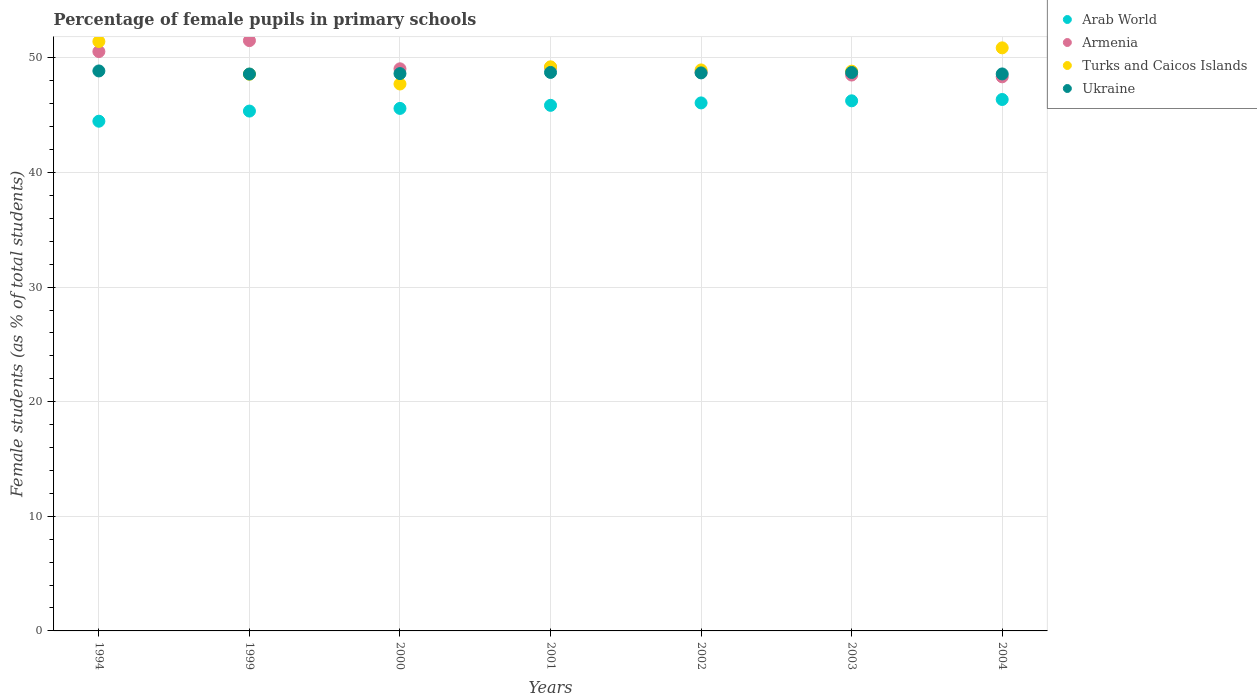How many different coloured dotlines are there?
Your answer should be compact. 4. Is the number of dotlines equal to the number of legend labels?
Offer a very short reply. Yes. What is the percentage of female pupils in primary schools in Arab World in 2000?
Offer a terse response. 45.59. Across all years, what is the maximum percentage of female pupils in primary schools in Arab World?
Your answer should be compact. 46.37. Across all years, what is the minimum percentage of female pupils in primary schools in Armenia?
Ensure brevity in your answer.  48.35. In which year was the percentage of female pupils in primary schools in Turks and Caicos Islands maximum?
Offer a very short reply. 1994. What is the total percentage of female pupils in primary schools in Turks and Caicos Islands in the graph?
Provide a succinct answer. 345.6. What is the difference between the percentage of female pupils in primary schools in Turks and Caicos Islands in 1999 and that in 2001?
Your response must be concise. -0.65. What is the difference between the percentage of female pupils in primary schools in Armenia in 2004 and the percentage of female pupils in primary schools in Ukraine in 2002?
Offer a very short reply. -0.34. What is the average percentage of female pupils in primary schools in Ukraine per year?
Offer a very short reply. 48.69. In the year 2002, what is the difference between the percentage of female pupils in primary schools in Ukraine and percentage of female pupils in primary schools in Arab World?
Your answer should be very brief. 2.62. In how many years, is the percentage of female pupils in primary schools in Armenia greater than 38 %?
Provide a succinct answer. 7. What is the ratio of the percentage of female pupils in primary schools in Turks and Caicos Islands in 2001 to that in 2003?
Provide a short and direct response. 1.01. Is the percentage of female pupils in primary schools in Arab World in 1999 less than that in 2003?
Provide a short and direct response. Yes. Is the difference between the percentage of female pupils in primary schools in Ukraine in 2003 and 2004 greater than the difference between the percentage of female pupils in primary schools in Arab World in 2003 and 2004?
Your response must be concise. Yes. What is the difference between the highest and the second highest percentage of female pupils in primary schools in Ukraine?
Ensure brevity in your answer.  0.13. What is the difference between the highest and the lowest percentage of female pupils in primary schools in Armenia?
Keep it short and to the point. 3.16. Is it the case that in every year, the sum of the percentage of female pupils in primary schools in Armenia and percentage of female pupils in primary schools in Arab World  is greater than the percentage of female pupils in primary schools in Ukraine?
Your answer should be very brief. Yes. Is the percentage of female pupils in primary schools in Turks and Caicos Islands strictly greater than the percentage of female pupils in primary schools in Ukraine over the years?
Keep it short and to the point. No. How many years are there in the graph?
Provide a succinct answer. 7. What is the difference between two consecutive major ticks on the Y-axis?
Provide a succinct answer. 10. How are the legend labels stacked?
Your response must be concise. Vertical. What is the title of the graph?
Provide a short and direct response. Percentage of female pupils in primary schools. Does "Bulgaria" appear as one of the legend labels in the graph?
Your answer should be compact. No. What is the label or title of the X-axis?
Offer a terse response. Years. What is the label or title of the Y-axis?
Your answer should be compact. Female students (as % of total students). What is the Female students (as % of total students) in Arab World in 1994?
Provide a succinct answer. 44.47. What is the Female students (as % of total students) of Armenia in 1994?
Offer a very short reply. 50.55. What is the Female students (as % of total students) in Turks and Caicos Islands in 1994?
Provide a short and direct response. 51.43. What is the Female students (as % of total students) of Ukraine in 1994?
Give a very brief answer. 48.86. What is the Female students (as % of total students) in Arab World in 1999?
Your answer should be very brief. 45.36. What is the Female students (as % of total students) of Armenia in 1999?
Your answer should be very brief. 51.51. What is the Female students (as % of total students) of Turks and Caicos Islands in 1999?
Provide a short and direct response. 48.57. What is the Female students (as % of total students) of Ukraine in 1999?
Your answer should be very brief. 48.59. What is the Female students (as % of total students) in Arab World in 2000?
Offer a very short reply. 45.59. What is the Female students (as % of total students) of Armenia in 2000?
Your answer should be compact. 49.05. What is the Female students (as % of total students) in Turks and Caicos Islands in 2000?
Provide a short and direct response. 47.72. What is the Female students (as % of total students) in Ukraine in 2000?
Make the answer very short. 48.63. What is the Female students (as % of total students) of Arab World in 2001?
Provide a short and direct response. 45.86. What is the Female students (as % of total students) in Armenia in 2001?
Give a very brief answer. 49.17. What is the Female students (as % of total students) of Turks and Caicos Islands in 2001?
Provide a succinct answer. 49.22. What is the Female students (as % of total students) of Ukraine in 2001?
Offer a very short reply. 48.73. What is the Female students (as % of total students) in Arab World in 2002?
Provide a succinct answer. 46.07. What is the Female students (as % of total students) in Armenia in 2002?
Offer a terse response. 48.74. What is the Female students (as % of total students) in Turks and Caicos Islands in 2002?
Your response must be concise. 48.95. What is the Female students (as % of total students) in Ukraine in 2002?
Your response must be concise. 48.69. What is the Female students (as % of total students) of Arab World in 2003?
Your answer should be very brief. 46.25. What is the Female students (as % of total students) of Armenia in 2003?
Make the answer very short. 48.5. What is the Female students (as % of total students) in Turks and Caicos Islands in 2003?
Offer a very short reply. 48.84. What is the Female students (as % of total students) in Ukraine in 2003?
Give a very brief answer. 48.72. What is the Female students (as % of total students) in Arab World in 2004?
Offer a terse response. 46.37. What is the Female students (as % of total students) of Armenia in 2004?
Provide a short and direct response. 48.35. What is the Female students (as % of total students) in Turks and Caicos Islands in 2004?
Give a very brief answer. 50.87. What is the Female students (as % of total students) of Ukraine in 2004?
Provide a succinct answer. 48.6. Across all years, what is the maximum Female students (as % of total students) of Arab World?
Give a very brief answer. 46.37. Across all years, what is the maximum Female students (as % of total students) in Armenia?
Give a very brief answer. 51.51. Across all years, what is the maximum Female students (as % of total students) in Turks and Caicos Islands?
Offer a very short reply. 51.43. Across all years, what is the maximum Female students (as % of total students) of Ukraine?
Offer a terse response. 48.86. Across all years, what is the minimum Female students (as % of total students) of Arab World?
Make the answer very short. 44.47. Across all years, what is the minimum Female students (as % of total students) of Armenia?
Offer a terse response. 48.35. Across all years, what is the minimum Female students (as % of total students) of Turks and Caicos Islands?
Your answer should be compact. 47.72. Across all years, what is the minimum Female students (as % of total students) of Ukraine?
Your answer should be very brief. 48.59. What is the total Female students (as % of total students) in Arab World in the graph?
Offer a very short reply. 319.97. What is the total Female students (as % of total students) of Armenia in the graph?
Give a very brief answer. 345.87. What is the total Female students (as % of total students) of Turks and Caicos Islands in the graph?
Provide a short and direct response. 345.6. What is the total Female students (as % of total students) in Ukraine in the graph?
Provide a succinct answer. 340.82. What is the difference between the Female students (as % of total students) of Arab World in 1994 and that in 1999?
Keep it short and to the point. -0.88. What is the difference between the Female students (as % of total students) of Armenia in 1994 and that in 1999?
Offer a very short reply. -0.95. What is the difference between the Female students (as % of total students) in Turks and Caicos Islands in 1994 and that in 1999?
Your answer should be compact. 2.86. What is the difference between the Female students (as % of total students) of Ukraine in 1994 and that in 1999?
Your response must be concise. 0.27. What is the difference between the Female students (as % of total students) of Arab World in 1994 and that in 2000?
Your answer should be very brief. -1.12. What is the difference between the Female students (as % of total students) in Armenia in 1994 and that in 2000?
Make the answer very short. 1.51. What is the difference between the Female students (as % of total students) in Turks and Caicos Islands in 1994 and that in 2000?
Provide a short and direct response. 3.71. What is the difference between the Female students (as % of total students) in Ukraine in 1994 and that in 2000?
Give a very brief answer. 0.23. What is the difference between the Female students (as % of total students) of Arab World in 1994 and that in 2001?
Keep it short and to the point. -1.38. What is the difference between the Female students (as % of total students) of Armenia in 1994 and that in 2001?
Your answer should be very brief. 1.38. What is the difference between the Female students (as % of total students) of Turks and Caicos Islands in 1994 and that in 2001?
Keep it short and to the point. 2.21. What is the difference between the Female students (as % of total students) in Ukraine in 1994 and that in 2001?
Give a very brief answer. 0.13. What is the difference between the Female students (as % of total students) in Arab World in 1994 and that in 2002?
Ensure brevity in your answer.  -1.6. What is the difference between the Female students (as % of total students) of Armenia in 1994 and that in 2002?
Keep it short and to the point. 1.81. What is the difference between the Female students (as % of total students) in Turks and Caicos Islands in 1994 and that in 2002?
Your answer should be very brief. 2.48. What is the difference between the Female students (as % of total students) of Ukraine in 1994 and that in 2002?
Your answer should be very brief. 0.17. What is the difference between the Female students (as % of total students) in Arab World in 1994 and that in 2003?
Give a very brief answer. -1.78. What is the difference between the Female students (as % of total students) in Armenia in 1994 and that in 2003?
Your response must be concise. 2.05. What is the difference between the Female students (as % of total students) of Turks and Caicos Islands in 1994 and that in 2003?
Your answer should be compact. 2.59. What is the difference between the Female students (as % of total students) of Ukraine in 1994 and that in 2003?
Give a very brief answer. 0.13. What is the difference between the Female students (as % of total students) in Arab World in 1994 and that in 2004?
Ensure brevity in your answer.  -1.9. What is the difference between the Female students (as % of total students) in Armenia in 1994 and that in 2004?
Offer a terse response. 2.2. What is the difference between the Female students (as % of total students) of Turks and Caicos Islands in 1994 and that in 2004?
Make the answer very short. 0.55. What is the difference between the Female students (as % of total students) in Ukraine in 1994 and that in 2004?
Your answer should be compact. 0.26. What is the difference between the Female students (as % of total students) of Arab World in 1999 and that in 2000?
Your response must be concise. -0.23. What is the difference between the Female students (as % of total students) in Armenia in 1999 and that in 2000?
Keep it short and to the point. 2.46. What is the difference between the Female students (as % of total students) in Turks and Caicos Islands in 1999 and that in 2000?
Your response must be concise. 0.85. What is the difference between the Female students (as % of total students) in Ukraine in 1999 and that in 2000?
Offer a very short reply. -0.04. What is the difference between the Female students (as % of total students) in Arab World in 1999 and that in 2001?
Provide a short and direct response. -0.5. What is the difference between the Female students (as % of total students) of Armenia in 1999 and that in 2001?
Ensure brevity in your answer.  2.33. What is the difference between the Female students (as % of total students) in Turks and Caicos Islands in 1999 and that in 2001?
Provide a succinct answer. -0.65. What is the difference between the Female students (as % of total students) in Ukraine in 1999 and that in 2001?
Give a very brief answer. -0.14. What is the difference between the Female students (as % of total students) in Arab World in 1999 and that in 2002?
Make the answer very short. -0.71. What is the difference between the Female students (as % of total students) of Armenia in 1999 and that in 2002?
Ensure brevity in your answer.  2.77. What is the difference between the Female students (as % of total students) of Turks and Caicos Islands in 1999 and that in 2002?
Your answer should be very brief. -0.37. What is the difference between the Female students (as % of total students) of Ukraine in 1999 and that in 2002?
Make the answer very short. -0.1. What is the difference between the Female students (as % of total students) of Arab World in 1999 and that in 2003?
Offer a terse response. -0.9. What is the difference between the Female students (as % of total students) of Armenia in 1999 and that in 2003?
Provide a short and direct response. 3. What is the difference between the Female students (as % of total students) of Turks and Caicos Islands in 1999 and that in 2003?
Keep it short and to the point. -0.27. What is the difference between the Female students (as % of total students) in Ukraine in 1999 and that in 2003?
Ensure brevity in your answer.  -0.13. What is the difference between the Female students (as % of total students) in Arab World in 1999 and that in 2004?
Your answer should be compact. -1.01. What is the difference between the Female students (as % of total students) of Armenia in 1999 and that in 2004?
Offer a terse response. 3.16. What is the difference between the Female students (as % of total students) in Turks and Caicos Islands in 1999 and that in 2004?
Offer a terse response. -2.3. What is the difference between the Female students (as % of total students) in Ukraine in 1999 and that in 2004?
Your answer should be very brief. -0.01. What is the difference between the Female students (as % of total students) of Arab World in 2000 and that in 2001?
Make the answer very short. -0.27. What is the difference between the Female students (as % of total students) of Armenia in 2000 and that in 2001?
Your answer should be very brief. -0.13. What is the difference between the Female students (as % of total students) of Turks and Caicos Islands in 2000 and that in 2001?
Your response must be concise. -1.5. What is the difference between the Female students (as % of total students) of Ukraine in 2000 and that in 2001?
Your answer should be compact. -0.1. What is the difference between the Female students (as % of total students) in Arab World in 2000 and that in 2002?
Ensure brevity in your answer.  -0.48. What is the difference between the Female students (as % of total students) in Armenia in 2000 and that in 2002?
Ensure brevity in your answer.  0.31. What is the difference between the Female students (as % of total students) in Turks and Caicos Islands in 2000 and that in 2002?
Provide a succinct answer. -1.23. What is the difference between the Female students (as % of total students) in Ukraine in 2000 and that in 2002?
Your response must be concise. -0.06. What is the difference between the Female students (as % of total students) in Arab World in 2000 and that in 2003?
Ensure brevity in your answer.  -0.66. What is the difference between the Female students (as % of total students) in Armenia in 2000 and that in 2003?
Keep it short and to the point. 0.54. What is the difference between the Female students (as % of total students) in Turks and Caicos Islands in 2000 and that in 2003?
Your response must be concise. -1.12. What is the difference between the Female students (as % of total students) of Ukraine in 2000 and that in 2003?
Provide a succinct answer. -0.1. What is the difference between the Female students (as % of total students) of Arab World in 2000 and that in 2004?
Provide a short and direct response. -0.78. What is the difference between the Female students (as % of total students) in Armenia in 2000 and that in 2004?
Offer a terse response. 0.7. What is the difference between the Female students (as % of total students) of Turks and Caicos Islands in 2000 and that in 2004?
Offer a terse response. -3.15. What is the difference between the Female students (as % of total students) in Ukraine in 2000 and that in 2004?
Offer a very short reply. 0.03. What is the difference between the Female students (as % of total students) in Arab World in 2001 and that in 2002?
Ensure brevity in your answer.  -0.21. What is the difference between the Female students (as % of total students) in Armenia in 2001 and that in 2002?
Keep it short and to the point. 0.43. What is the difference between the Female students (as % of total students) of Turks and Caicos Islands in 2001 and that in 2002?
Your answer should be compact. 0.27. What is the difference between the Female students (as % of total students) in Ukraine in 2001 and that in 2002?
Ensure brevity in your answer.  0.04. What is the difference between the Female students (as % of total students) in Arab World in 2001 and that in 2003?
Make the answer very short. -0.39. What is the difference between the Female students (as % of total students) of Armenia in 2001 and that in 2003?
Offer a terse response. 0.67. What is the difference between the Female students (as % of total students) in Turks and Caicos Islands in 2001 and that in 2003?
Your answer should be very brief. 0.38. What is the difference between the Female students (as % of total students) of Ukraine in 2001 and that in 2003?
Keep it short and to the point. 0.01. What is the difference between the Female students (as % of total students) in Arab World in 2001 and that in 2004?
Offer a terse response. -0.51. What is the difference between the Female students (as % of total students) in Armenia in 2001 and that in 2004?
Your response must be concise. 0.83. What is the difference between the Female students (as % of total students) of Turks and Caicos Islands in 2001 and that in 2004?
Your answer should be very brief. -1.66. What is the difference between the Female students (as % of total students) in Ukraine in 2001 and that in 2004?
Provide a succinct answer. 0.13. What is the difference between the Female students (as % of total students) in Arab World in 2002 and that in 2003?
Offer a very short reply. -0.18. What is the difference between the Female students (as % of total students) in Armenia in 2002 and that in 2003?
Your response must be concise. 0.24. What is the difference between the Female students (as % of total students) of Turks and Caicos Islands in 2002 and that in 2003?
Ensure brevity in your answer.  0.11. What is the difference between the Female students (as % of total students) of Ukraine in 2002 and that in 2003?
Make the answer very short. -0.04. What is the difference between the Female students (as % of total students) of Arab World in 2002 and that in 2004?
Offer a terse response. -0.3. What is the difference between the Female students (as % of total students) of Armenia in 2002 and that in 2004?
Provide a succinct answer. 0.39. What is the difference between the Female students (as % of total students) in Turks and Caicos Islands in 2002 and that in 2004?
Provide a succinct answer. -1.93. What is the difference between the Female students (as % of total students) in Ukraine in 2002 and that in 2004?
Provide a succinct answer. 0.09. What is the difference between the Female students (as % of total students) of Arab World in 2003 and that in 2004?
Your response must be concise. -0.12. What is the difference between the Female students (as % of total students) of Armenia in 2003 and that in 2004?
Provide a short and direct response. 0.15. What is the difference between the Female students (as % of total students) in Turks and Caicos Islands in 2003 and that in 2004?
Make the answer very short. -2.03. What is the difference between the Female students (as % of total students) in Ukraine in 2003 and that in 2004?
Keep it short and to the point. 0.13. What is the difference between the Female students (as % of total students) of Arab World in 1994 and the Female students (as % of total students) of Armenia in 1999?
Provide a short and direct response. -7.03. What is the difference between the Female students (as % of total students) of Arab World in 1994 and the Female students (as % of total students) of Turks and Caicos Islands in 1999?
Your response must be concise. -4.1. What is the difference between the Female students (as % of total students) of Arab World in 1994 and the Female students (as % of total students) of Ukraine in 1999?
Provide a succinct answer. -4.12. What is the difference between the Female students (as % of total students) of Armenia in 1994 and the Female students (as % of total students) of Turks and Caicos Islands in 1999?
Your answer should be very brief. 1.98. What is the difference between the Female students (as % of total students) in Armenia in 1994 and the Female students (as % of total students) in Ukraine in 1999?
Provide a succinct answer. 1.96. What is the difference between the Female students (as % of total students) in Turks and Caicos Islands in 1994 and the Female students (as % of total students) in Ukraine in 1999?
Your response must be concise. 2.84. What is the difference between the Female students (as % of total students) in Arab World in 1994 and the Female students (as % of total students) in Armenia in 2000?
Make the answer very short. -4.57. What is the difference between the Female students (as % of total students) in Arab World in 1994 and the Female students (as % of total students) in Turks and Caicos Islands in 2000?
Provide a succinct answer. -3.25. What is the difference between the Female students (as % of total students) in Arab World in 1994 and the Female students (as % of total students) in Ukraine in 2000?
Provide a short and direct response. -4.15. What is the difference between the Female students (as % of total students) of Armenia in 1994 and the Female students (as % of total students) of Turks and Caicos Islands in 2000?
Offer a terse response. 2.83. What is the difference between the Female students (as % of total students) of Armenia in 1994 and the Female students (as % of total students) of Ukraine in 2000?
Offer a very short reply. 1.92. What is the difference between the Female students (as % of total students) of Turks and Caicos Islands in 1994 and the Female students (as % of total students) of Ukraine in 2000?
Your answer should be very brief. 2.8. What is the difference between the Female students (as % of total students) in Arab World in 1994 and the Female students (as % of total students) in Armenia in 2001?
Your response must be concise. -4.7. What is the difference between the Female students (as % of total students) of Arab World in 1994 and the Female students (as % of total students) of Turks and Caicos Islands in 2001?
Ensure brevity in your answer.  -4.75. What is the difference between the Female students (as % of total students) of Arab World in 1994 and the Female students (as % of total students) of Ukraine in 2001?
Make the answer very short. -4.26. What is the difference between the Female students (as % of total students) of Armenia in 1994 and the Female students (as % of total students) of Turks and Caicos Islands in 2001?
Make the answer very short. 1.33. What is the difference between the Female students (as % of total students) of Armenia in 1994 and the Female students (as % of total students) of Ukraine in 2001?
Provide a succinct answer. 1.82. What is the difference between the Female students (as % of total students) in Turks and Caicos Islands in 1994 and the Female students (as % of total students) in Ukraine in 2001?
Ensure brevity in your answer.  2.7. What is the difference between the Female students (as % of total students) in Arab World in 1994 and the Female students (as % of total students) in Armenia in 2002?
Your response must be concise. -4.27. What is the difference between the Female students (as % of total students) of Arab World in 1994 and the Female students (as % of total students) of Turks and Caicos Islands in 2002?
Keep it short and to the point. -4.47. What is the difference between the Female students (as % of total students) in Arab World in 1994 and the Female students (as % of total students) in Ukraine in 2002?
Offer a very short reply. -4.22. What is the difference between the Female students (as % of total students) of Armenia in 1994 and the Female students (as % of total students) of Turks and Caicos Islands in 2002?
Your answer should be compact. 1.6. What is the difference between the Female students (as % of total students) of Armenia in 1994 and the Female students (as % of total students) of Ukraine in 2002?
Your answer should be compact. 1.86. What is the difference between the Female students (as % of total students) in Turks and Caicos Islands in 1994 and the Female students (as % of total students) in Ukraine in 2002?
Keep it short and to the point. 2.74. What is the difference between the Female students (as % of total students) in Arab World in 1994 and the Female students (as % of total students) in Armenia in 2003?
Ensure brevity in your answer.  -4.03. What is the difference between the Female students (as % of total students) in Arab World in 1994 and the Female students (as % of total students) in Turks and Caicos Islands in 2003?
Keep it short and to the point. -4.37. What is the difference between the Female students (as % of total students) of Arab World in 1994 and the Female students (as % of total students) of Ukraine in 2003?
Your answer should be very brief. -4.25. What is the difference between the Female students (as % of total students) in Armenia in 1994 and the Female students (as % of total students) in Turks and Caicos Islands in 2003?
Ensure brevity in your answer.  1.71. What is the difference between the Female students (as % of total students) of Armenia in 1994 and the Female students (as % of total students) of Ukraine in 2003?
Your response must be concise. 1.83. What is the difference between the Female students (as % of total students) of Turks and Caicos Islands in 1994 and the Female students (as % of total students) of Ukraine in 2003?
Provide a succinct answer. 2.7. What is the difference between the Female students (as % of total students) in Arab World in 1994 and the Female students (as % of total students) in Armenia in 2004?
Give a very brief answer. -3.87. What is the difference between the Female students (as % of total students) of Arab World in 1994 and the Female students (as % of total students) of Turks and Caicos Islands in 2004?
Your answer should be compact. -6.4. What is the difference between the Female students (as % of total students) in Arab World in 1994 and the Female students (as % of total students) in Ukraine in 2004?
Give a very brief answer. -4.12. What is the difference between the Female students (as % of total students) of Armenia in 1994 and the Female students (as % of total students) of Turks and Caicos Islands in 2004?
Make the answer very short. -0.32. What is the difference between the Female students (as % of total students) of Armenia in 1994 and the Female students (as % of total students) of Ukraine in 2004?
Your answer should be compact. 1.95. What is the difference between the Female students (as % of total students) of Turks and Caicos Islands in 1994 and the Female students (as % of total students) of Ukraine in 2004?
Offer a terse response. 2.83. What is the difference between the Female students (as % of total students) of Arab World in 1999 and the Female students (as % of total students) of Armenia in 2000?
Offer a very short reply. -3.69. What is the difference between the Female students (as % of total students) of Arab World in 1999 and the Female students (as % of total students) of Turks and Caicos Islands in 2000?
Make the answer very short. -2.36. What is the difference between the Female students (as % of total students) in Arab World in 1999 and the Female students (as % of total students) in Ukraine in 2000?
Offer a terse response. -3.27. What is the difference between the Female students (as % of total students) in Armenia in 1999 and the Female students (as % of total students) in Turks and Caicos Islands in 2000?
Your answer should be very brief. 3.79. What is the difference between the Female students (as % of total students) of Armenia in 1999 and the Female students (as % of total students) of Ukraine in 2000?
Give a very brief answer. 2.88. What is the difference between the Female students (as % of total students) of Turks and Caicos Islands in 1999 and the Female students (as % of total students) of Ukraine in 2000?
Your response must be concise. -0.05. What is the difference between the Female students (as % of total students) of Arab World in 1999 and the Female students (as % of total students) of Armenia in 2001?
Give a very brief answer. -3.82. What is the difference between the Female students (as % of total students) in Arab World in 1999 and the Female students (as % of total students) in Turks and Caicos Islands in 2001?
Make the answer very short. -3.86. What is the difference between the Female students (as % of total students) of Arab World in 1999 and the Female students (as % of total students) of Ukraine in 2001?
Your answer should be very brief. -3.37. What is the difference between the Female students (as % of total students) of Armenia in 1999 and the Female students (as % of total students) of Turks and Caicos Islands in 2001?
Your response must be concise. 2.29. What is the difference between the Female students (as % of total students) of Armenia in 1999 and the Female students (as % of total students) of Ukraine in 2001?
Provide a succinct answer. 2.78. What is the difference between the Female students (as % of total students) of Turks and Caicos Islands in 1999 and the Female students (as % of total students) of Ukraine in 2001?
Your answer should be compact. -0.16. What is the difference between the Female students (as % of total students) in Arab World in 1999 and the Female students (as % of total students) in Armenia in 2002?
Your response must be concise. -3.38. What is the difference between the Female students (as % of total students) in Arab World in 1999 and the Female students (as % of total students) in Turks and Caicos Islands in 2002?
Offer a very short reply. -3.59. What is the difference between the Female students (as % of total students) of Arab World in 1999 and the Female students (as % of total students) of Ukraine in 2002?
Give a very brief answer. -3.33. What is the difference between the Female students (as % of total students) in Armenia in 1999 and the Female students (as % of total students) in Turks and Caicos Islands in 2002?
Offer a very short reply. 2.56. What is the difference between the Female students (as % of total students) of Armenia in 1999 and the Female students (as % of total students) of Ukraine in 2002?
Provide a succinct answer. 2.82. What is the difference between the Female students (as % of total students) of Turks and Caicos Islands in 1999 and the Female students (as % of total students) of Ukraine in 2002?
Provide a succinct answer. -0.12. What is the difference between the Female students (as % of total students) of Arab World in 1999 and the Female students (as % of total students) of Armenia in 2003?
Ensure brevity in your answer.  -3.14. What is the difference between the Female students (as % of total students) of Arab World in 1999 and the Female students (as % of total students) of Turks and Caicos Islands in 2003?
Your answer should be very brief. -3.48. What is the difference between the Female students (as % of total students) of Arab World in 1999 and the Female students (as % of total students) of Ukraine in 2003?
Ensure brevity in your answer.  -3.37. What is the difference between the Female students (as % of total students) of Armenia in 1999 and the Female students (as % of total students) of Turks and Caicos Islands in 2003?
Keep it short and to the point. 2.67. What is the difference between the Female students (as % of total students) in Armenia in 1999 and the Female students (as % of total students) in Ukraine in 2003?
Your answer should be compact. 2.78. What is the difference between the Female students (as % of total students) of Turks and Caicos Islands in 1999 and the Female students (as % of total students) of Ukraine in 2003?
Your answer should be very brief. -0.15. What is the difference between the Female students (as % of total students) in Arab World in 1999 and the Female students (as % of total students) in Armenia in 2004?
Your answer should be compact. -2.99. What is the difference between the Female students (as % of total students) of Arab World in 1999 and the Female students (as % of total students) of Turks and Caicos Islands in 2004?
Make the answer very short. -5.52. What is the difference between the Female students (as % of total students) in Arab World in 1999 and the Female students (as % of total students) in Ukraine in 2004?
Offer a terse response. -3.24. What is the difference between the Female students (as % of total students) in Armenia in 1999 and the Female students (as % of total students) in Turks and Caicos Islands in 2004?
Provide a succinct answer. 0.63. What is the difference between the Female students (as % of total students) of Armenia in 1999 and the Female students (as % of total students) of Ukraine in 2004?
Make the answer very short. 2.91. What is the difference between the Female students (as % of total students) in Turks and Caicos Islands in 1999 and the Female students (as % of total students) in Ukraine in 2004?
Provide a succinct answer. -0.03. What is the difference between the Female students (as % of total students) in Arab World in 2000 and the Female students (as % of total students) in Armenia in 2001?
Your response must be concise. -3.58. What is the difference between the Female students (as % of total students) in Arab World in 2000 and the Female students (as % of total students) in Turks and Caicos Islands in 2001?
Provide a succinct answer. -3.63. What is the difference between the Female students (as % of total students) of Arab World in 2000 and the Female students (as % of total students) of Ukraine in 2001?
Your answer should be compact. -3.14. What is the difference between the Female students (as % of total students) in Armenia in 2000 and the Female students (as % of total students) in Turks and Caicos Islands in 2001?
Your response must be concise. -0.17. What is the difference between the Female students (as % of total students) of Armenia in 2000 and the Female students (as % of total students) of Ukraine in 2001?
Offer a very short reply. 0.32. What is the difference between the Female students (as % of total students) in Turks and Caicos Islands in 2000 and the Female students (as % of total students) in Ukraine in 2001?
Offer a very short reply. -1.01. What is the difference between the Female students (as % of total students) of Arab World in 2000 and the Female students (as % of total students) of Armenia in 2002?
Give a very brief answer. -3.15. What is the difference between the Female students (as % of total students) in Arab World in 2000 and the Female students (as % of total students) in Turks and Caicos Islands in 2002?
Provide a short and direct response. -3.36. What is the difference between the Female students (as % of total students) of Arab World in 2000 and the Female students (as % of total students) of Ukraine in 2002?
Your answer should be very brief. -3.1. What is the difference between the Female students (as % of total students) in Armenia in 2000 and the Female students (as % of total students) in Turks and Caicos Islands in 2002?
Your answer should be compact. 0.1. What is the difference between the Female students (as % of total students) of Armenia in 2000 and the Female students (as % of total students) of Ukraine in 2002?
Your answer should be very brief. 0.36. What is the difference between the Female students (as % of total students) in Turks and Caicos Islands in 2000 and the Female students (as % of total students) in Ukraine in 2002?
Offer a terse response. -0.97. What is the difference between the Female students (as % of total students) of Arab World in 2000 and the Female students (as % of total students) of Armenia in 2003?
Your response must be concise. -2.91. What is the difference between the Female students (as % of total students) in Arab World in 2000 and the Female students (as % of total students) in Turks and Caicos Islands in 2003?
Your answer should be very brief. -3.25. What is the difference between the Female students (as % of total students) of Arab World in 2000 and the Female students (as % of total students) of Ukraine in 2003?
Make the answer very short. -3.13. What is the difference between the Female students (as % of total students) in Armenia in 2000 and the Female students (as % of total students) in Turks and Caicos Islands in 2003?
Your answer should be compact. 0.21. What is the difference between the Female students (as % of total students) in Armenia in 2000 and the Female students (as % of total students) in Ukraine in 2003?
Offer a very short reply. 0.32. What is the difference between the Female students (as % of total students) in Turks and Caicos Islands in 2000 and the Female students (as % of total students) in Ukraine in 2003?
Offer a very short reply. -1. What is the difference between the Female students (as % of total students) of Arab World in 2000 and the Female students (as % of total students) of Armenia in 2004?
Ensure brevity in your answer.  -2.76. What is the difference between the Female students (as % of total students) in Arab World in 2000 and the Female students (as % of total students) in Turks and Caicos Islands in 2004?
Offer a terse response. -5.28. What is the difference between the Female students (as % of total students) of Arab World in 2000 and the Female students (as % of total students) of Ukraine in 2004?
Your answer should be compact. -3.01. What is the difference between the Female students (as % of total students) of Armenia in 2000 and the Female students (as % of total students) of Turks and Caicos Islands in 2004?
Your answer should be very brief. -1.83. What is the difference between the Female students (as % of total students) of Armenia in 2000 and the Female students (as % of total students) of Ukraine in 2004?
Your answer should be compact. 0.45. What is the difference between the Female students (as % of total students) of Turks and Caicos Islands in 2000 and the Female students (as % of total students) of Ukraine in 2004?
Your answer should be very brief. -0.88. What is the difference between the Female students (as % of total students) of Arab World in 2001 and the Female students (as % of total students) of Armenia in 2002?
Keep it short and to the point. -2.88. What is the difference between the Female students (as % of total students) of Arab World in 2001 and the Female students (as % of total students) of Turks and Caicos Islands in 2002?
Offer a terse response. -3.09. What is the difference between the Female students (as % of total students) in Arab World in 2001 and the Female students (as % of total students) in Ukraine in 2002?
Provide a short and direct response. -2.83. What is the difference between the Female students (as % of total students) in Armenia in 2001 and the Female students (as % of total students) in Turks and Caicos Islands in 2002?
Ensure brevity in your answer.  0.23. What is the difference between the Female students (as % of total students) in Armenia in 2001 and the Female students (as % of total students) in Ukraine in 2002?
Your answer should be very brief. 0.49. What is the difference between the Female students (as % of total students) in Turks and Caicos Islands in 2001 and the Female students (as % of total students) in Ukraine in 2002?
Provide a succinct answer. 0.53. What is the difference between the Female students (as % of total students) of Arab World in 2001 and the Female students (as % of total students) of Armenia in 2003?
Your answer should be very brief. -2.64. What is the difference between the Female students (as % of total students) in Arab World in 2001 and the Female students (as % of total students) in Turks and Caicos Islands in 2003?
Offer a very short reply. -2.98. What is the difference between the Female students (as % of total students) in Arab World in 2001 and the Female students (as % of total students) in Ukraine in 2003?
Keep it short and to the point. -2.87. What is the difference between the Female students (as % of total students) of Armenia in 2001 and the Female students (as % of total students) of Turks and Caicos Islands in 2003?
Your answer should be compact. 0.33. What is the difference between the Female students (as % of total students) in Armenia in 2001 and the Female students (as % of total students) in Ukraine in 2003?
Your response must be concise. 0.45. What is the difference between the Female students (as % of total students) of Turks and Caicos Islands in 2001 and the Female students (as % of total students) of Ukraine in 2003?
Your response must be concise. 0.49. What is the difference between the Female students (as % of total students) in Arab World in 2001 and the Female students (as % of total students) in Armenia in 2004?
Provide a succinct answer. -2.49. What is the difference between the Female students (as % of total students) in Arab World in 2001 and the Female students (as % of total students) in Turks and Caicos Islands in 2004?
Ensure brevity in your answer.  -5.02. What is the difference between the Female students (as % of total students) in Arab World in 2001 and the Female students (as % of total students) in Ukraine in 2004?
Your answer should be very brief. -2.74. What is the difference between the Female students (as % of total students) in Armenia in 2001 and the Female students (as % of total students) in Turks and Caicos Islands in 2004?
Your answer should be very brief. -1.7. What is the difference between the Female students (as % of total students) of Armenia in 2001 and the Female students (as % of total students) of Ukraine in 2004?
Offer a very short reply. 0.58. What is the difference between the Female students (as % of total students) in Turks and Caicos Islands in 2001 and the Female students (as % of total students) in Ukraine in 2004?
Provide a succinct answer. 0.62. What is the difference between the Female students (as % of total students) of Arab World in 2002 and the Female students (as % of total students) of Armenia in 2003?
Keep it short and to the point. -2.43. What is the difference between the Female students (as % of total students) of Arab World in 2002 and the Female students (as % of total students) of Turks and Caicos Islands in 2003?
Ensure brevity in your answer.  -2.77. What is the difference between the Female students (as % of total students) of Arab World in 2002 and the Female students (as % of total students) of Ukraine in 2003?
Offer a very short reply. -2.66. What is the difference between the Female students (as % of total students) in Armenia in 2002 and the Female students (as % of total students) in Turks and Caicos Islands in 2003?
Your answer should be very brief. -0.1. What is the difference between the Female students (as % of total students) of Armenia in 2002 and the Female students (as % of total students) of Ukraine in 2003?
Offer a very short reply. 0.01. What is the difference between the Female students (as % of total students) in Turks and Caicos Islands in 2002 and the Female students (as % of total students) in Ukraine in 2003?
Your response must be concise. 0.22. What is the difference between the Female students (as % of total students) of Arab World in 2002 and the Female students (as % of total students) of Armenia in 2004?
Provide a succinct answer. -2.28. What is the difference between the Female students (as % of total students) in Arab World in 2002 and the Female students (as % of total students) in Turks and Caicos Islands in 2004?
Offer a terse response. -4.8. What is the difference between the Female students (as % of total students) of Arab World in 2002 and the Female students (as % of total students) of Ukraine in 2004?
Provide a short and direct response. -2.53. What is the difference between the Female students (as % of total students) in Armenia in 2002 and the Female students (as % of total students) in Turks and Caicos Islands in 2004?
Keep it short and to the point. -2.13. What is the difference between the Female students (as % of total students) of Armenia in 2002 and the Female students (as % of total students) of Ukraine in 2004?
Ensure brevity in your answer.  0.14. What is the difference between the Female students (as % of total students) in Turks and Caicos Islands in 2002 and the Female students (as % of total students) in Ukraine in 2004?
Your response must be concise. 0.35. What is the difference between the Female students (as % of total students) in Arab World in 2003 and the Female students (as % of total students) in Armenia in 2004?
Keep it short and to the point. -2.09. What is the difference between the Female students (as % of total students) in Arab World in 2003 and the Female students (as % of total students) in Turks and Caicos Islands in 2004?
Offer a terse response. -4.62. What is the difference between the Female students (as % of total students) of Arab World in 2003 and the Female students (as % of total students) of Ukraine in 2004?
Provide a succinct answer. -2.35. What is the difference between the Female students (as % of total students) in Armenia in 2003 and the Female students (as % of total students) in Turks and Caicos Islands in 2004?
Give a very brief answer. -2.37. What is the difference between the Female students (as % of total students) of Armenia in 2003 and the Female students (as % of total students) of Ukraine in 2004?
Keep it short and to the point. -0.1. What is the difference between the Female students (as % of total students) in Turks and Caicos Islands in 2003 and the Female students (as % of total students) in Ukraine in 2004?
Your answer should be compact. 0.24. What is the average Female students (as % of total students) in Arab World per year?
Your response must be concise. 45.71. What is the average Female students (as % of total students) of Armenia per year?
Your response must be concise. 49.41. What is the average Female students (as % of total students) of Turks and Caicos Islands per year?
Keep it short and to the point. 49.37. What is the average Female students (as % of total students) in Ukraine per year?
Ensure brevity in your answer.  48.69. In the year 1994, what is the difference between the Female students (as % of total students) in Arab World and Female students (as % of total students) in Armenia?
Give a very brief answer. -6.08. In the year 1994, what is the difference between the Female students (as % of total students) of Arab World and Female students (as % of total students) of Turks and Caicos Islands?
Give a very brief answer. -6.95. In the year 1994, what is the difference between the Female students (as % of total students) in Arab World and Female students (as % of total students) in Ukraine?
Offer a very short reply. -4.39. In the year 1994, what is the difference between the Female students (as % of total students) in Armenia and Female students (as % of total students) in Turks and Caicos Islands?
Your answer should be compact. -0.88. In the year 1994, what is the difference between the Female students (as % of total students) in Armenia and Female students (as % of total students) in Ukraine?
Your answer should be compact. 1.69. In the year 1994, what is the difference between the Female students (as % of total students) of Turks and Caicos Islands and Female students (as % of total students) of Ukraine?
Provide a succinct answer. 2.57. In the year 1999, what is the difference between the Female students (as % of total students) of Arab World and Female students (as % of total students) of Armenia?
Provide a short and direct response. -6.15. In the year 1999, what is the difference between the Female students (as % of total students) in Arab World and Female students (as % of total students) in Turks and Caicos Islands?
Your answer should be very brief. -3.21. In the year 1999, what is the difference between the Female students (as % of total students) of Arab World and Female students (as % of total students) of Ukraine?
Provide a succinct answer. -3.23. In the year 1999, what is the difference between the Female students (as % of total students) in Armenia and Female students (as % of total students) in Turks and Caicos Islands?
Your response must be concise. 2.93. In the year 1999, what is the difference between the Female students (as % of total students) in Armenia and Female students (as % of total students) in Ukraine?
Keep it short and to the point. 2.91. In the year 1999, what is the difference between the Female students (as % of total students) in Turks and Caicos Islands and Female students (as % of total students) in Ukraine?
Your response must be concise. -0.02. In the year 2000, what is the difference between the Female students (as % of total students) of Arab World and Female students (as % of total students) of Armenia?
Give a very brief answer. -3.46. In the year 2000, what is the difference between the Female students (as % of total students) in Arab World and Female students (as % of total students) in Turks and Caicos Islands?
Give a very brief answer. -2.13. In the year 2000, what is the difference between the Female students (as % of total students) in Arab World and Female students (as % of total students) in Ukraine?
Your response must be concise. -3.04. In the year 2000, what is the difference between the Female students (as % of total students) in Armenia and Female students (as % of total students) in Turks and Caicos Islands?
Offer a terse response. 1.33. In the year 2000, what is the difference between the Female students (as % of total students) in Armenia and Female students (as % of total students) in Ukraine?
Your response must be concise. 0.42. In the year 2000, what is the difference between the Female students (as % of total students) in Turks and Caicos Islands and Female students (as % of total students) in Ukraine?
Make the answer very short. -0.91. In the year 2001, what is the difference between the Female students (as % of total students) in Arab World and Female students (as % of total students) in Armenia?
Offer a very short reply. -3.32. In the year 2001, what is the difference between the Female students (as % of total students) of Arab World and Female students (as % of total students) of Turks and Caicos Islands?
Your response must be concise. -3.36. In the year 2001, what is the difference between the Female students (as % of total students) of Arab World and Female students (as % of total students) of Ukraine?
Provide a short and direct response. -2.87. In the year 2001, what is the difference between the Female students (as % of total students) in Armenia and Female students (as % of total students) in Turks and Caicos Islands?
Provide a succinct answer. -0.04. In the year 2001, what is the difference between the Female students (as % of total students) of Armenia and Female students (as % of total students) of Ukraine?
Your answer should be compact. 0.44. In the year 2001, what is the difference between the Female students (as % of total students) in Turks and Caicos Islands and Female students (as % of total students) in Ukraine?
Provide a short and direct response. 0.49. In the year 2002, what is the difference between the Female students (as % of total students) in Arab World and Female students (as % of total students) in Armenia?
Offer a terse response. -2.67. In the year 2002, what is the difference between the Female students (as % of total students) of Arab World and Female students (as % of total students) of Turks and Caicos Islands?
Ensure brevity in your answer.  -2.88. In the year 2002, what is the difference between the Female students (as % of total students) in Arab World and Female students (as % of total students) in Ukraine?
Your answer should be very brief. -2.62. In the year 2002, what is the difference between the Female students (as % of total students) in Armenia and Female students (as % of total students) in Turks and Caicos Islands?
Provide a short and direct response. -0.21. In the year 2002, what is the difference between the Female students (as % of total students) in Armenia and Female students (as % of total students) in Ukraine?
Your response must be concise. 0.05. In the year 2002, what is the difference between the Female students (as % of total students) in Turks and Caicos Islands and Female students (as % of total students) in Ukraine?
Make the answer very short. 0.26. In the year 2003, what is the difference between the Female students (as % of total students) of Arab World and Female students (as % of total students) of Armenia?
Your answer should be compact. -2.25. In the year 2003, what is the difference between the Female students (as % of total students) of Arab World and Female students (as % of total students) of Turks and Caicos Islands?
Your response must be concise. -2.59. In the year 2003, what is the difference between the Female students (as % of total students) in Arab World and Female students (as % of total students) in Ukraine?
Make the answer very short. -2.47. In the year 2003, what is the difference between the Female students (as % of total students) of Armenia and Female students (as % of total students) of Turks and Caicos Islands?
Ensure brevity in your answer.  -0.34. In the year 2003, what is the difference between the Female students (as % of total students) in Armenia and Female students (as % of total students) in Ukraine?
Ensure brevity in your answer.  -0.22. In the year 2003, what is the difference between the Female students (as % of total students) of Turks and Caicos Islands and Female students (as % of total students) of Ukraine?
Your answer should be compact. 0.11. In the year 2004, what is the difference between the Female students (as % of total students) in Arab World and Female students (as % of total students) in Armenia?
Provide a succinct answer. -1.98. In the year 2004, what is the difference between the Female students (as % of total students) of Arab World and Female students (as % of total students) of Turks and Caicos Islands?
Your answer should be very brief. -4.51. In the year 2004, what is the difference between the Female students (as % of total students) of Arab World and Female students (as % of total students) of Ukraine?
Make the answer very short. -2.23. In the year 2004, what is the difference between the Female students (as % of total students) of Armenia and Female students (as % of total students) of Turks and Caicos Islands?
Offer a terse response. -2.53. In the year 2004, what is the difference between the Female students (as % of total students) of Armenia and Female students (as % of total students) of Ukraine?
Give a very brief answer. -0.25. In the year 2004, what is the difference between the Female students (as % of total students) in Turks and Caicos Islands and Female students (as % of total students) in Ukraine?
Offer a very short reply. 2.28. What is the ratio of the Female students (as % of total students) of Arab World in 1994 to that in 1999?
Your answer should be very brief. 0.98. What is the ratio of the Female students (as % of total students) in Armenia in 1994 to that in 1999?
Make the answer very short. 0.98. What is the ratio of the Female students (as % of total students) in Turks and Caicos Islands in 1994 to that in 1999?
Make the answer very short. 1.06. What is the ratio of the Female students (as % of total students) in Arab World in 1994 to that in 2000?
Your answer should be compact. 0.98. What is the ratio of the Female students (as % of total students) of Armenia in 1994 to that in 2000?
Provide a succinct answer. 1.03. What is the ratio of the Female students (as % of total students) in Turks and Caicos Islands in 1994 to that in 2000?
Ensure brevity in your answer.  1.08. What is the ratio of the Female students (as % of total students) in Arab World in 1994 to that in 2001?
Offer a very short reply. 0.97. What is the ratio of the Female students (as % of total students) of Armenia in 1994 to that in 2001?
Offer a very short reply. 1.03. What is the ratio of the Female students (as % of total students) in Turks and Caicos Islands in 1994 to that in 2001?
Provide a short and direct response. 1.04. What is the ratio of the Female students (as % of total students) in Ukraine in 1994 to that in 2001?
Give a very brief answer. 1. What is the ratio of the Female students (as % of total students) of Arab World in 1994 to that in 2002?
Keep it short and to the point. 0.97. What is the ratio of the Female students (as % of total students) of Armenia in 1994 to that in 2002?
Give a very brief answer. 1.04. What is the ratio of the Female students (as % of total students) in Turks and Caicos Islands in 1994 to that in 2002?
Your answer should be very brief. 1.05. What is the ratio of the Female students (as % of total students) of Arab World in 1994 to that in 2003?
Your response must be concise. 0.96. What is the ratio of the Female students (as % of total students) in Armenia in 1994 to that in 2003?
Offer a terse response. 1.04. What is the ratio of the Female students (as % of total students) in Turks and Caicos Islands in 1994 to that in 2003?
Make the answer very short. 1.05. What is the ratio of the Female students (as % of total students) of Ukraine in 1994 to that in 2003?
Ensure brevity in your answer.  1. What is the ratio of the Female students (as % of total students) of Arab World in 1994 to that in 2004?
Keep it short and to the point. 0.96. What is the ratio of the Female students (as % of total students) in Armenia in 1994 to that in 2004?
Ensure brevity in your answer.  1.05. What is the ratio of the Female students (as % of total students) in Turks and Caicos Islands in 1994 to that in 2004?
Make the answer very short. 1.01. What is the ratio of the Female students (as % of total students) of Ukraine in 1994 to that in 2004?
Make the answer very short. 1.01. What is the ratio of the Female students (as % of total students) in Arab World in 1999 to that in 2000?
Make the answer very short. 0.99. What is the ratio of the Female students (as % of total students) of Armenia in 1999 to that in 2000?
Your answer should be compact. 1.05. What is the ratio of the Female students (as % of total students) of Turks and Caicos Islands in 1999 to that in 2000?
Offer a very short reply. 1.02. What is the ratio of the Female students (as % of total students) in Arab World in 1999 to that in 2001?
Your answer should be compact. 0.99. What is the ratio of the Female students (as % of total students) in Armenia in 1999 to that in 2001?
Your answer should be very brief. 1.05. What is the ratio of the Female students (as % of total students) in Turks and Caicos Islands in 1999 to that in 2001?
Offer a very short reply. 0.99. What is the ratio of the Female students (as % of total students) in Arab World in 1999 to that in 2002?
Provide a short and direct response. 0.98. What is the ratio of the Female students (as % of total students) of Armenia in 1999 to that in 2002?
Provide a succinct answer. 1.06. What is the ratio of the Female students (as % of total students) in Ukraine in 1999 to that in 2002?
Your answer should be very brief. 1. What is the ratio of the Female students (as % of total students) of Arab World in 1999 to that in 2003?
Offer a terse response. 0.98. What is the ratio of the Female students (as % of total students) in Armenia in 1999 to that in 2003?
Give a very brief answer. 1.06. What is the ratio of the Female students (as % of total students) in Arab World in 1999 to that in 2004?
Keep it short and to the point. 0.98. What is the ratio of the Female students (as % of total students) in Armenia in 1999 to that in 2004?
Your answer should be very brief. 1.07. What is the ratio of the Female students (as % of total students) of Turks and Caicos Islands in 1999 to that in 2004?
Ensure brevity in your answer.  0.95. What is the ratio of the Female students (as % of total students) of Ukraine in 1999 to that in 2004?
Keep it short and to the point. 1. What is the ratio of the Female students (as % of total students) of Arab World in 2000 to that in 2001?
Keep it short and to the point. 0.99. What is the ratio of the Female students (as % of total students) of Armenia in 2000 to that in 2001?
Keep it short and to the point. 1. What is the ratio of the Female students (as % of total students) in Turks and Caicos Islands in 2000 to that in 2001?
Provide a succinct answer. 0.97. What is the ratio of the Female students (as % of total students) in Turks and Caicos Islands in 2000 to that in 2002?
Ensure brevity in your answer.  0.97. What is the ratio of the Female students (as % of total students) in Arab World in 2000 to that in 2003?
Your answer should be compact. 0.99. What is the ratio of the Female students (as % of total students) in Armenia in 2000 to that in 2003?
Provide a short and direct response. 1.01. What is the ratio of the Female students (as % of total students) of Turks and Caicos Islands in 2000 to that in 2003?
Make the answer very short. 0.98. What is the ratio of the Female students (as % of total students) of Ukraine in 2000 to that in 2003?
Give a very brief answer. 1. What is the ratio of the Female students (as % of total students) in Arab World in 2000 to that in 2004?
Offer a very short reply. 0.98. What is the ratio of the Female students (as % of total students) in Armenia in 2000 to that in 2004?
Offer a terse response. 1.01. What is the ratio of the Female students (as % of total students) of Turks and Caicos Islands in 2000 to that in 2004?
Ensure brevity in your answer.  0.94. What is the ratio of the Female students (as % of total students) of Armenia in 2001 to that in 2002?
Your answer should be very brief. 1.01. What is the ratio of the Female students (as % of total students) in Turks and Caicos Islands in 2001 to that in 2002?
Provide a short and direct response. 1.01. What is the ratio of the Female students (as % of total students) of Ukraine in 2001 to that in 2002?
Make the answer very short. 1. What is the ratio of the Female students (as % of total students) in Arab World in 2001 to that in 2003?
Provide a succinct answer. 0.99. What is the ratio of the Female students (as % of total students) of Armenia in 2001 to that in 2003?
Keep it short and to the point. 1.01. What is the ratio of the Female students (as % of total students) in Ukraine in 2001 to that in 2003?
Make the answer very short. 1. What is the ratio of the Female students (as % of total students) in Arab World in 2001 to that in 2004?
Your answer should be very brief. 0.99. What is the ratio of the Female students (as % of total students) in Armenia in 2001 to that in 2004?
Ensure brevity in your answer.  1.02. What is the ratio of the Female students (as % of total students) of Turks and Caicos Islands in 2001 to that in 2004?
Provide a short and direct response. 0.97. What is the ratio of the Female students (as % of total students) in Arab World in 2002 to that in 2003?
Offer a very short reply. 1. What is the ratio of the Female students (as % of total students) in Turks and Caicos Islands in 2002 to that in 2003?
Make the answer very short. 1. What is the ratio of the Female students (as % of total students) in Arab World in 2002 to that in 2004?
Your answer should be very brief. 0.99. What is the ratio of the Female students (as % of total students) of Turks and Caicos Islands in 2002 to that in 2004?
Make the answer very short. 0.96. What is the ratio of the Female students (as % of total students) of Arab World in 2003 to that in 2004?
Offer a terse response. 1. What is the ratio of the Female students (as % of total students) of Turks and Caicos Islands in 2003 to that in 2004?
Make the answer very short. 0.96. What is the ratio of the Female students (as % of total students) of Ukraine in 2003 to that in 2004?
Your answer should be very brief. 1. What is the difference between the highest and the second highest Female students (as % of total students) in Arab World?
Make the answer very short. 0.12. What is the difference between the highest and the second highest Female students (as % of total students) of Armenia?
Offer a terse response. 0.95. What is the difference between the highest and the second highest Female students (as % of total students) in Turks and Caicos Islands?
Your answer should be very brief. 0.55. What is the difference between the highest and the second highest Female students (as % of total students) in Ukraine?
Make the answer very short. 0.13. What is the difference between the highest and the lowest Female students (as % of total students) in Arab World?
Provide a short and direct response. 1.9. What is the difference between the highest and the lowest Female students (as % of total students) of Armenia?
Your answer should be compact. 3.16. What is the difference between the highest and the lowest Female students (as % of total students) of Turks and Caicos Islands?
Give a very brief answer. 3.71. What is the difference between the highest and the lowest Female students (as % of total students) of Ukraine?
Your answer should be compact. 0.27. 